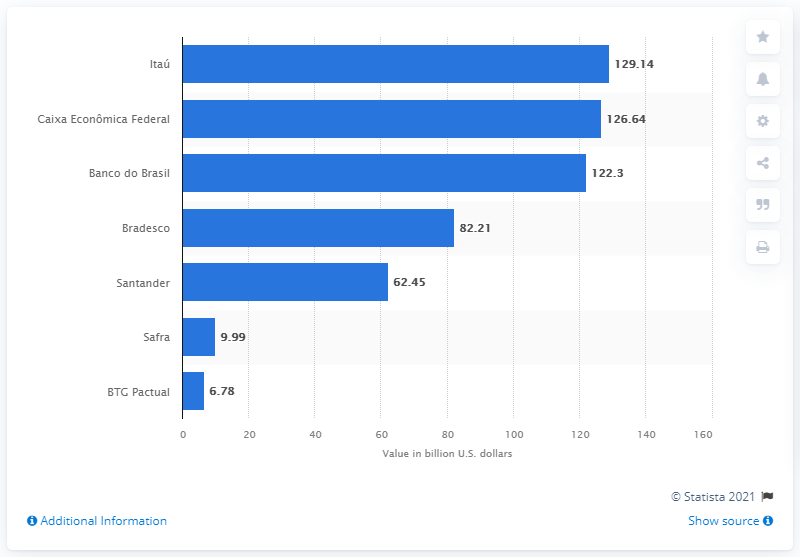What is the approximate difference in deposit values between the top-ranked bank and the last-ranked bank in this image? The approximate difference in deposit values between the top-ranked bank, Itaú, and the last-ranked bank, BTC Pactual, is around 122.36 billion U.S. dollars. 